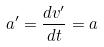<formula> <loc_0><loc_0><loc_500><loc_500>a ^ { \prime } = \frac { d v ^ { \prime } } { d t } = a</formula> 